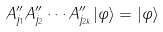<formula> <loc_0><loc_0><loc_500><loc_500>A ^ { \prime \prime } _ { j _ { 1 } } A ^ { \prime \prime } _ { j _ { 2 } } \cdots A ^ { \prime \prime } _ { j _ { 2 k } } | \varphi \rangle = | \varphi \rangle</formula> 